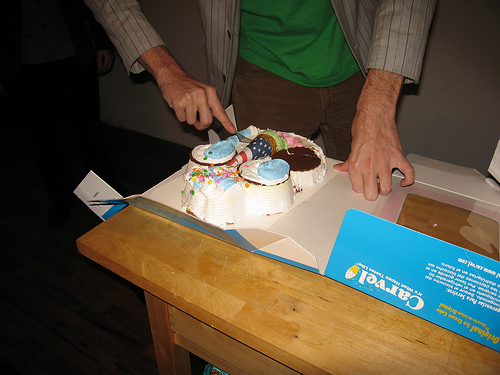What can you say about the person who is cutting the cake? The person cutting the cake appears to be wearing a shirt with rolled-up sleeves, suggesting they are dressed in a casual manner. Their stance indicates they are in the midst of cutting the cake, possibly serving it to others at the event. 